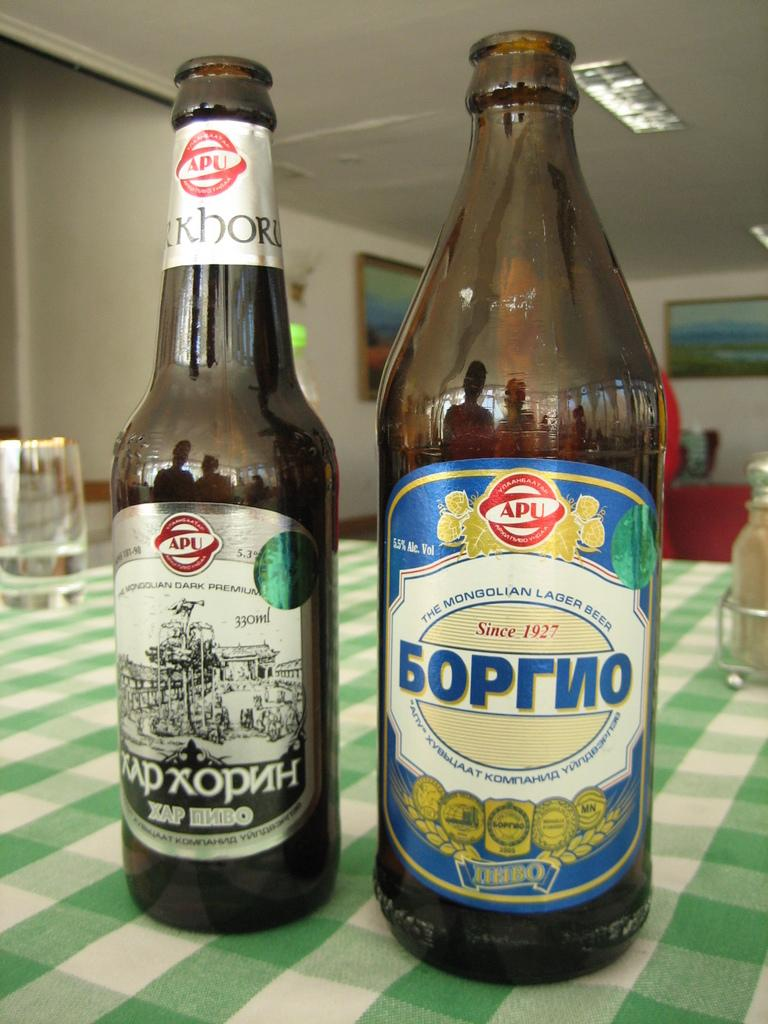<image>
Present a compact description of the photo's key features. The beer was made by "The Mongolian Lager Beer" company. 